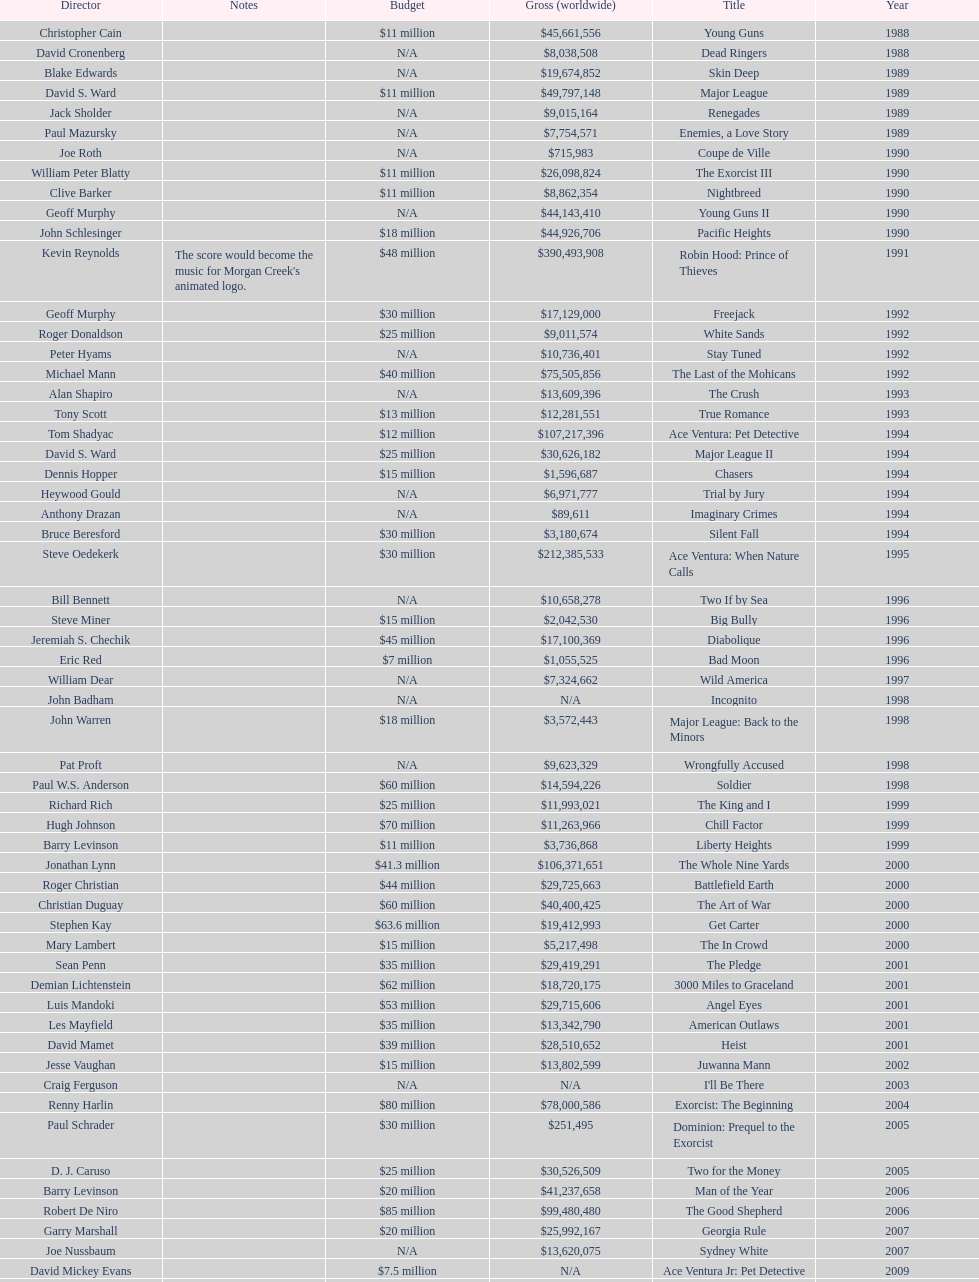Was the budget for young guns more or less than freejack's budget? Less. 